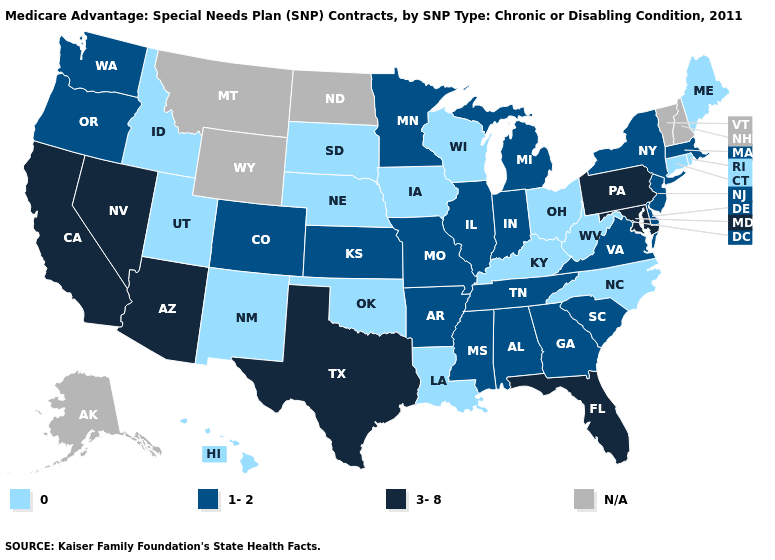What is the value of Indiana?
Write a very short answer. 1-2. What is the value of California?
Quick response, please. 3-8. What is the highest value in states that border Indiana?
Short answer required. 1-2. Name the states that have a value in the range 0?
Quick response, please. Connecticut, Hawaii, Iowa, Idaho, Kentucky, Louisiana, Maine, North Carolina, Nebraska, New Mexico, Ohio, Oklahoma, Rhode Island, South Dakota, Utah, Wisconsin, West Virginia. Does the first symbol in the legend represent the smallest category?
Give a very brief answer. Yes. What is the lowest value in the South?
Write a very short answer. 0. What is the value of Montana?
Write a very short answer. N/A. Does the map have missing data?
Keep it brief. Yes. Name the states that have a value in the range 3-8?
Short answer required. Arizona, California, Florida, Maryland, Nevada, Pennsylvania, Texas. Among the states that border Utah , which have the lowest value?
Keep it brief. Idaho, New Mexico. Name the states that have a value in the range 3-8?
Answer briefly. Arizona, California, Florida, Maryland, Nevada, Pennsylvania, Texas. What is the value of Wisconsin?
Concise answer only. 0. Which states hav the highest value in the South?
Concise answer only. Florida, Maryland, Texas. 